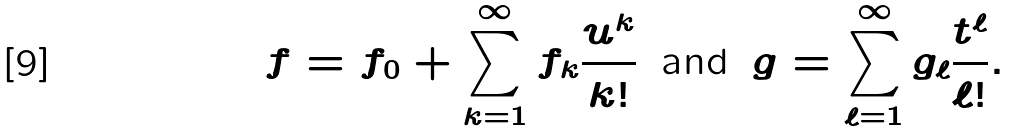<formula> <loc_0><loc_0><loc_500><loc_500>f = f _ { 0 } + \sum _ { k = 1 } ^ { \infty } f _ { k } \frac { u ^ { k } } { k ! } \, \text { and } \, g = \sum _ { \ell = 1 } ^ { \infty } g _ { \ell } \frac { t ^ { \ell } } { \ell ! } .</formula> 